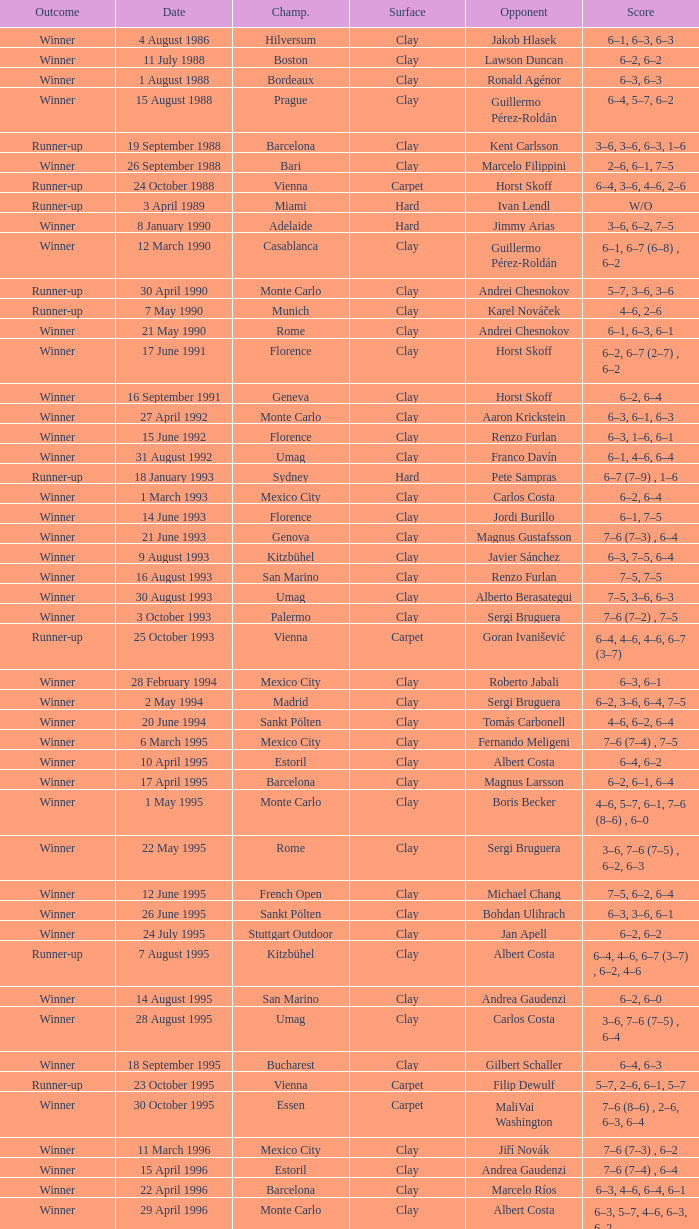What is the score when the championship is rome and the opponent is richard krajicek? 6–2, 6–4, 3–6, 6–3. 